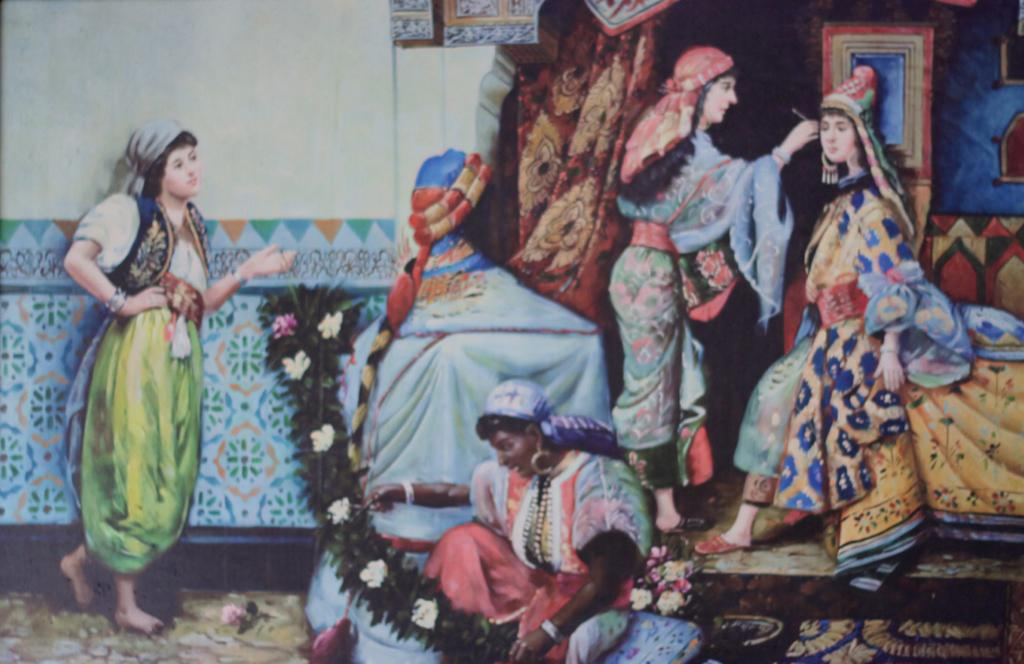What is the main subject of the image? The main subject of the image is a painting. What is depicted in the painting? The painting depicts a few women. What type of sound can be heard coming from the painting in the image? There is no sound present in the image, as it is a painting and not a video or audio recording. 